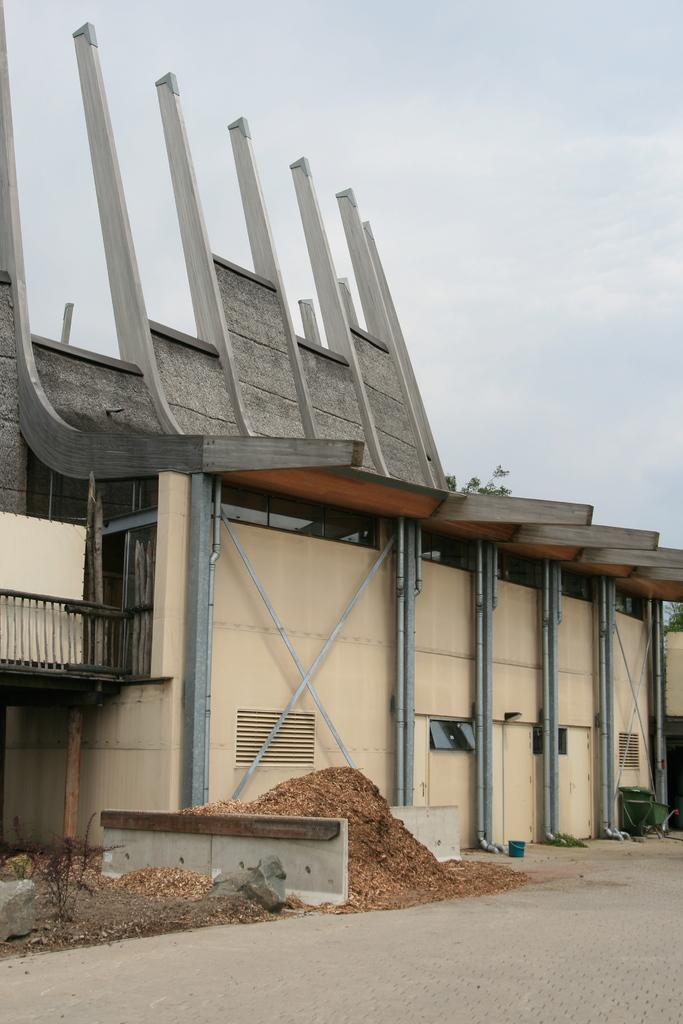What is the main subject in the middle of the image? There is a building in the middle of the image. What can be seen in the background of the image? The sky is visible in the background of the image. What type of baseball is being played in the image? There is no baseball or any indication of a baseball game in the image. 